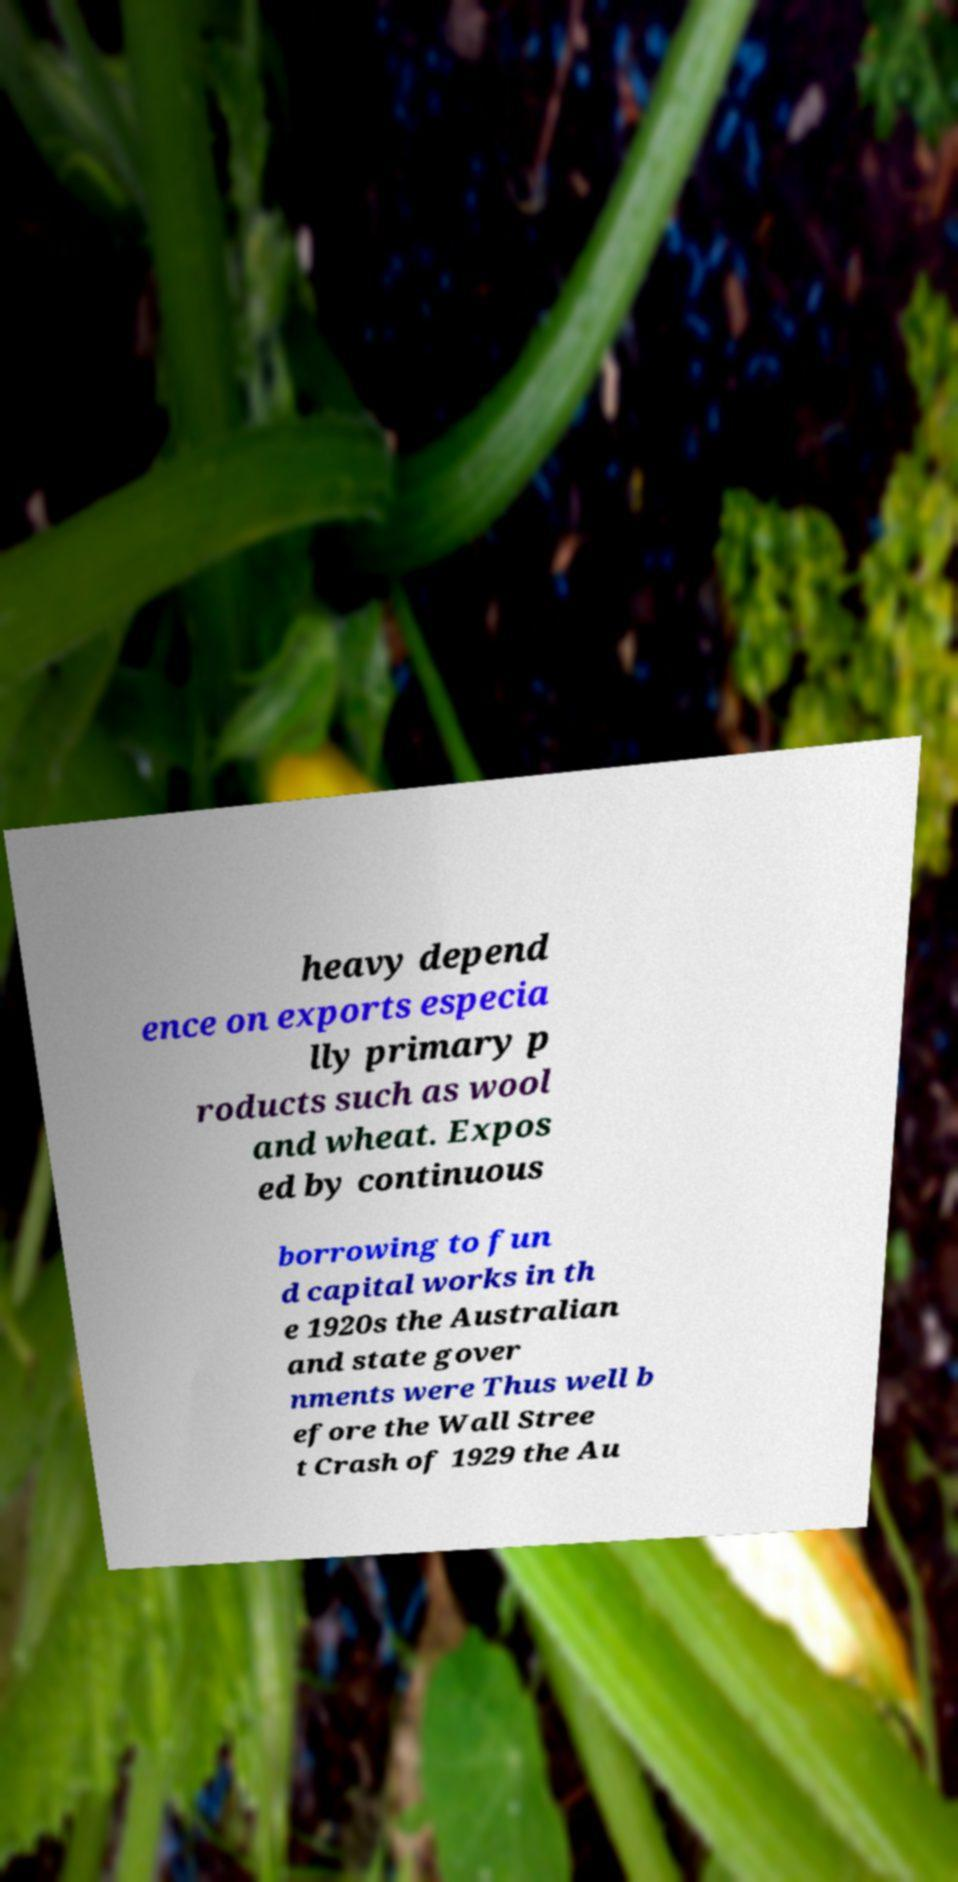Please identify and transcribe the text found in this image. heavy depend ence on exports especia lly primary p roducts such as wool and wheat. Expos ed by continuous borrowing to fun d capital works in th e 1920s the Australian and state gover nments were Thus well b efore the Wall Stree t Crash of 1929 the Au 